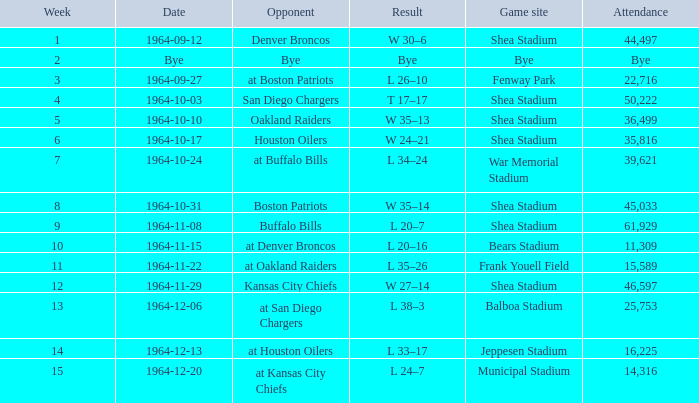In what venue did the jets have a game with an attendance of 11,309? Bears Stadium. 